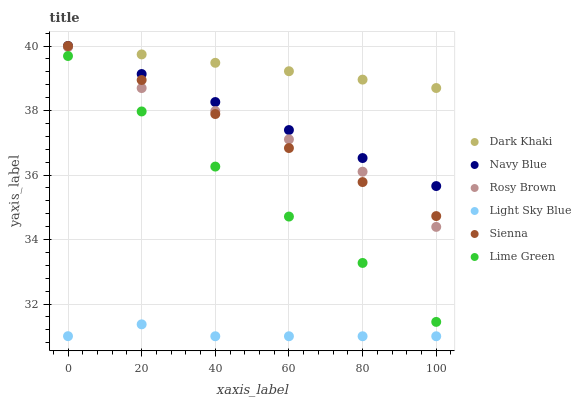Does Light Sky Blue have the minimum area under the curve?
Answer yes or no. Yes. Does Dark Khaki have the maximum area under the curve?
Answer yes or no. Yes. Does Navy Blue have the minimum area under the curve?
Answer yes or no. No. Does Navy Blue have the maximum area under the curve?
Answer yes or no. No. Is Sienna the smoothest?
Answer yes or no. Yes. Is Rosy Brown the roughest?
Answer yes or no. Yes. Is Navy Blue the smoothest?
Answer yes or no. No. Is Navy Blue the roughest?
Answer yes or no. No. Does Light Sky Blue have the lowest value?
Answer yes or no. Yes. Does Navy Blue have the lowest value?
Answer yes or no. No. Does Dark Khaki have the highest value?
Answer yes or no. Yes. Does Rosy Brown have the highest value?
Answer yes or no. No. Is Light Sky Blue less than Dark Khaki?
Answer yes or no. Yes. Is Lime Green greater than Light Sky Blue?
Answer yes or no. Yes. Does Rosy Brown intersect Sienna?
Answer yes or no. Yes. Is Rosy Brown less than Sienna?
Answer yes or no. No. Is Rosy Brown greater than Sienna?
Answer yes or no. No. Does Light Sky Blue intersect Dark Khaki?
Answer yes or no. No. 